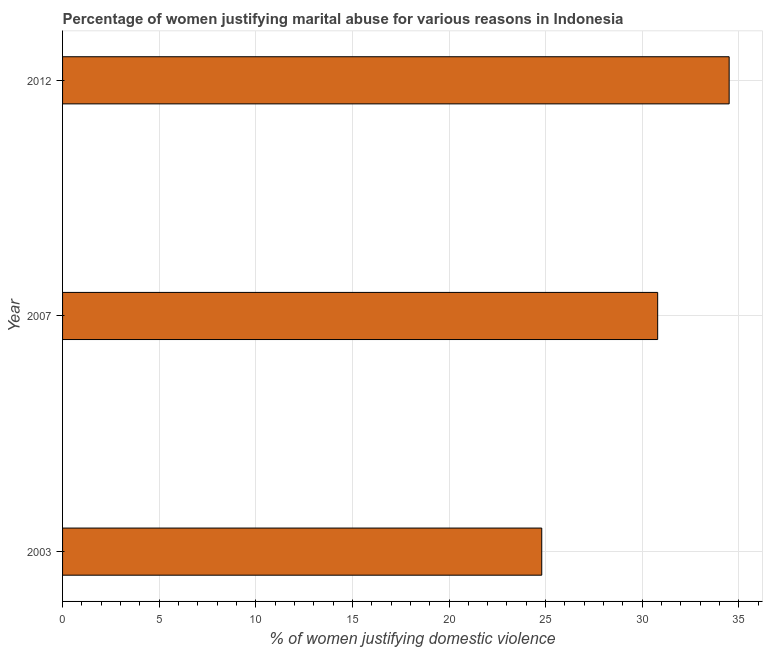Does the graph contain any zero values?
Offer a terse response. No. Does the graph contain grids?
Your answer should be very brief. Yes. What is the title of the graph?
Your answer should be very brief. Percentage of women justifying marital abuse for various reasons in Indonesia. What is the label or title of the X-axis?
Give a very brief answer. % of women justifying domestic violence. What is the percentage of women justifying marital abuse in 2003?
Provide a short and direct response. 24.8. Across all years, what is the maximum percentage of women justifying marital abuse?
Give a very brief answer. 34.5. Across all years, what is the minimum percentage of women justifying marital abuse?
Provide a succinct answer. 24.8. In which year was the percentage of women justifying marital abuse maximum?
Offer a terse response. 2012. In which year was the percentage of women justifying marital abuse minimum?
Your response must be concise. 2003. What is the sum of the percentage of women justifying marital abuse?
Offer a terse response. 90.1. What is the average percentage of women justifying marital abuse per year?
Keep it short and to the point. 30.03. What is the median percentage of women justifying marital abuse?
Provide a short and direct response. 30.8. In how many years, is the percentage of women justifying marital abuse greater than 33 %?
Your answer should be compact. 1. Do a majority of the years between 2007 and 2012 (inclusive) have percentage of women justifying marital abuse greater than 15 %?
Your response must be concise. Yes. What is the ratio of the percentage of women justifying marital abuse in 2007 to that in 2012?
Provide a succinct answer. 0.89. Is the percentage of women justifying marital abuse in 2003 less than that in 2007?
Make the answer very short. Yes. What is the difference between the highest and the second highest percentage of women justifying marital abuse?
Your answer should be very brief. 3.7. Is the sum of the percentage of women justifying marital abuse in 2007 and 2012 greater than the maximum percentage of women justifying marital abuse across all years?
Your answer should be compact. Yes. In how many years, is the percentage of women justifying marital abuse greater than the average percentage of women justifying marital abuse taken over all years?
Make the answer very short. 2. How many bars are there?
Your answer should be compact. 3. How many years are there in the graph?
Give a very brief answer. 3. What is the % of women justifying domestic violence of 2003?
Give a very brief answer. 24.8. What is the % of women justifying domestic violence in 2007?
Your answer should be very brief. 30.8. What is the % of women justifying domestic violence of 2012?
Give a very brief answer. 34.5. What is the difference between the % of women justifying domestic violence in 2003 and 2007?
Offer a very short reply. -6. What is the difference between the % of women justifying domestic violence in 2003 and 2012?
Offer a terse response. -9.7. What is the ratio of the % of women justifying domestic violence in 2003 to that in 2007?
Offer a very short reply. 0.81. What is the ratio of the % of women justifying domestic violence in 2003 to that in 2012?
Keep it short and to the point. 0.72. What is the ratio of the % of women justifying domestic violence in 2007 to that in 2012?
Offer a very short reply. 0.89. 